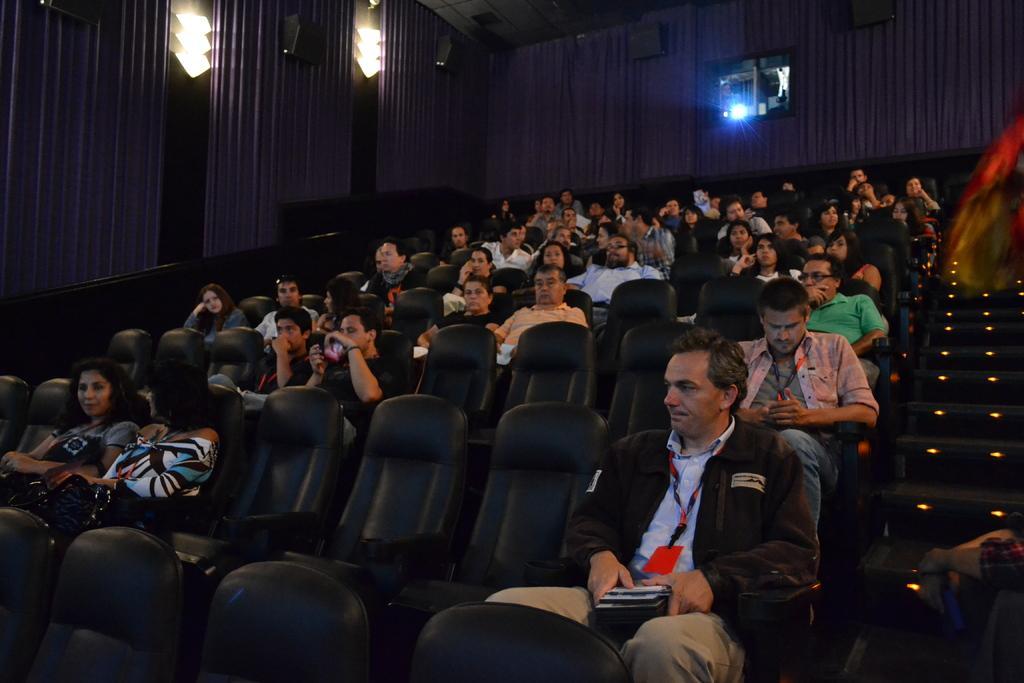How would you summarize this image in a sentence or two? In this image people are sitting on chairs, in the background there are curtains speakers and projector. 